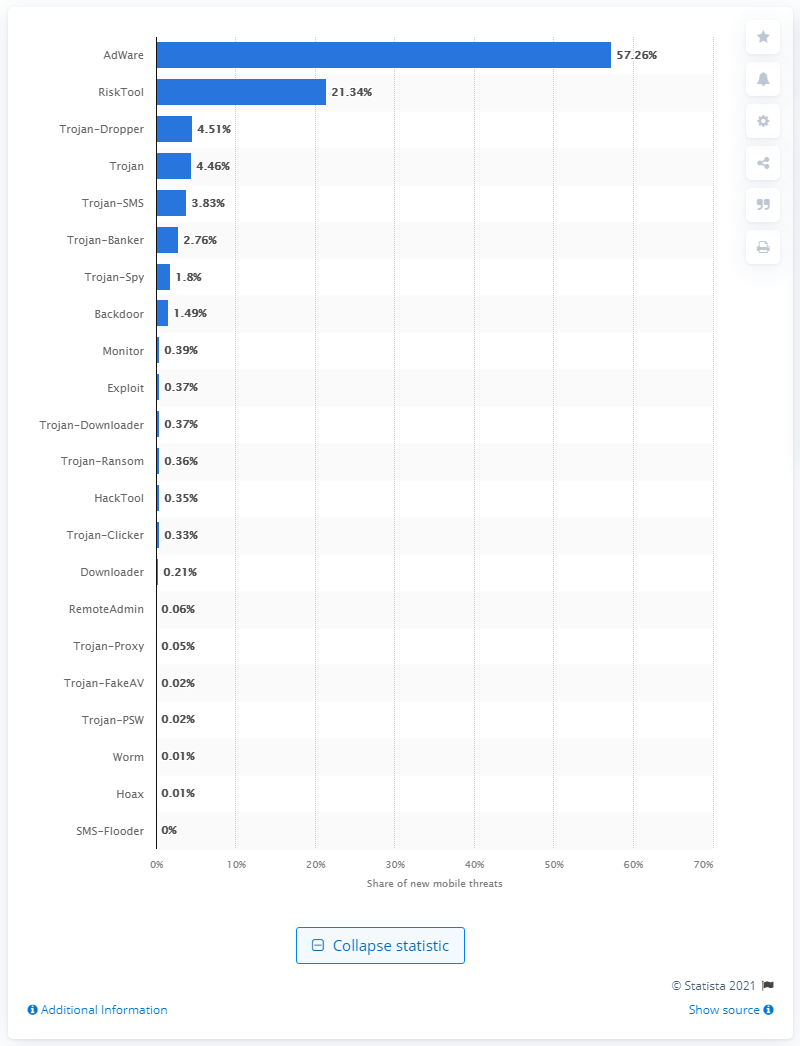List a handful of essential elements in this visual. In 2020, AdWare accounted for 57.26% of the new mobile malware worldwide, making it the primary source of malware for mobile devices. According to the data, the second-ranked company had a 21.34% share of all new threats in 2020, and it was RiskTool. 